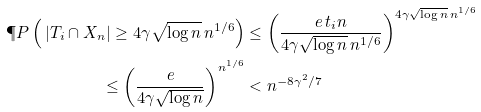Convert formula to latex. <formula><loc_0><loc_0><loc_500><loc_500>\P P \left ( \, | T _ { i } \cap X _ { n } | \geq 4 \gamma \sqrt { \log n } \, n ^ { 1 / 6 } \right ) & \leq \left ( \frac { e \, t _ { i } n } { 4 \gamma \sqrt { \log n } \, n ^ { 1 / 6 } } \right ) ^ { 4 \gamma \sqrt { \log n } \, n ^ { 1 / 6 } } \\ \leq \left ( \frac { e } { 4 \gamma \sqrt { \log n } } \right ) ^ { n ^ { 1 / 6 } } & < n ^ { - 8 \gamma ^ { 2 } / 7 }</formula> 